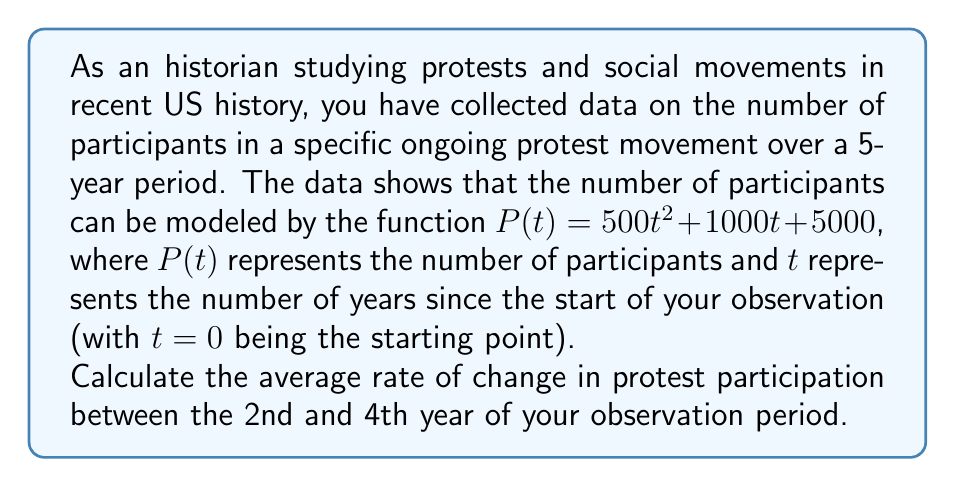Can you solve this math problem? To solve this problem, we need to follow these steps:

1) The average rate of change between two points is given by the formula:

   $$\text{Average rate of change} = \frac{\text{Change in } y}{\text{Change in } x} = \frac{y_2 - y_1}{x_2 - x_1}$$

2) In this case, we need to calculate:

   $$\frac{P(4) - P(2)}{4 - 2}$$

3) Let's calculate $P(2)$ and $P(4)$:

   $P(2) = 500(2)^2 + 1000(2) + 5000 = 2000 + 2000 + 5000 = 9000$

   $P(4) = 500(4)^2 + 1000(4) + 5000 = 8000 + 4000 + 5000 = 17000$

4) Now we can substitute these values into our rate of change formula:

   $$\text{Average rate of change} = \frac{17000 - 9000}{4 - 2} = \frac{8000}{2} = 4000$$

5) Therefore, the average rate of change in protest participation between the 2nd and 4th year is 4000 participants per year.
Answer: 4000 participants per year 